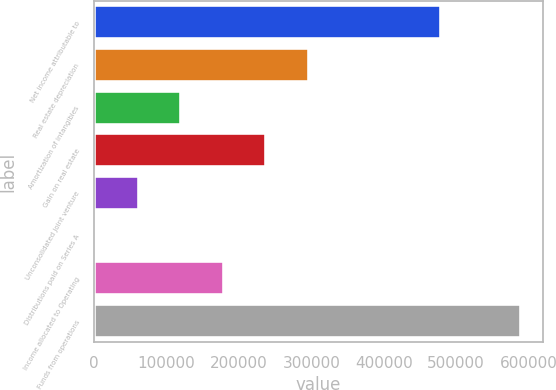<chart> <loc_0><loc_0><loc_500><loc_500><bar_chart><fcel>Net income attributable to<fcel>Real estate depreciation<fcel>Amortization of intangibles<fcel>Gain on real estate<fcel>Unconsolidated joint venture<fcel>Distributions paid on Series A<fcel>Income allocated to Operating<fcel>Funds from operations<nl><fcel>479013<fcel>296635<fcel>120525<fcel>237932<fcel>61822.2<fcel>3119<fcel>179229<fcel>590151<nl></chart> 